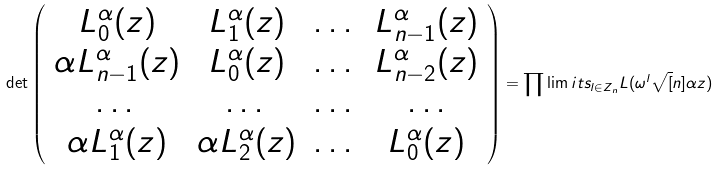Convert formula to latex. <formula><loc_0><loc_0><loc_500><loc_500>\det \left ( \begin{array} { c c c c } L _ { 0 } ^ { \alpha } ( z ) & L _ { 1 } ^ { \alpha } ( z ) & \dots & L _ { n - 1 } ^ { \alpha } ( z ) \\ \alpha L _ { n - 1 } ^ { \alpha } ( z ) & L _ { 0 } ^ { \alpha } ( z ) & \dots & L _ { n - 2 } ^ { \alpha } ( z ) \\ \dots & \dots & \dots & \dots \\ \alpha L _ { 1 } ^ { \alpha } ( z ) & \alpha L _ { 2 } ^ { \alpha } ( z ) & \dots & L _ { 0 } ^ { \alpha } ( z ) \end{array} \right ) = \prod \lim i t s _ { l \in Z _ { n } } L ( \omega ^ { l } \sqrt { [ } n ] { \alpha } z )</formula> 